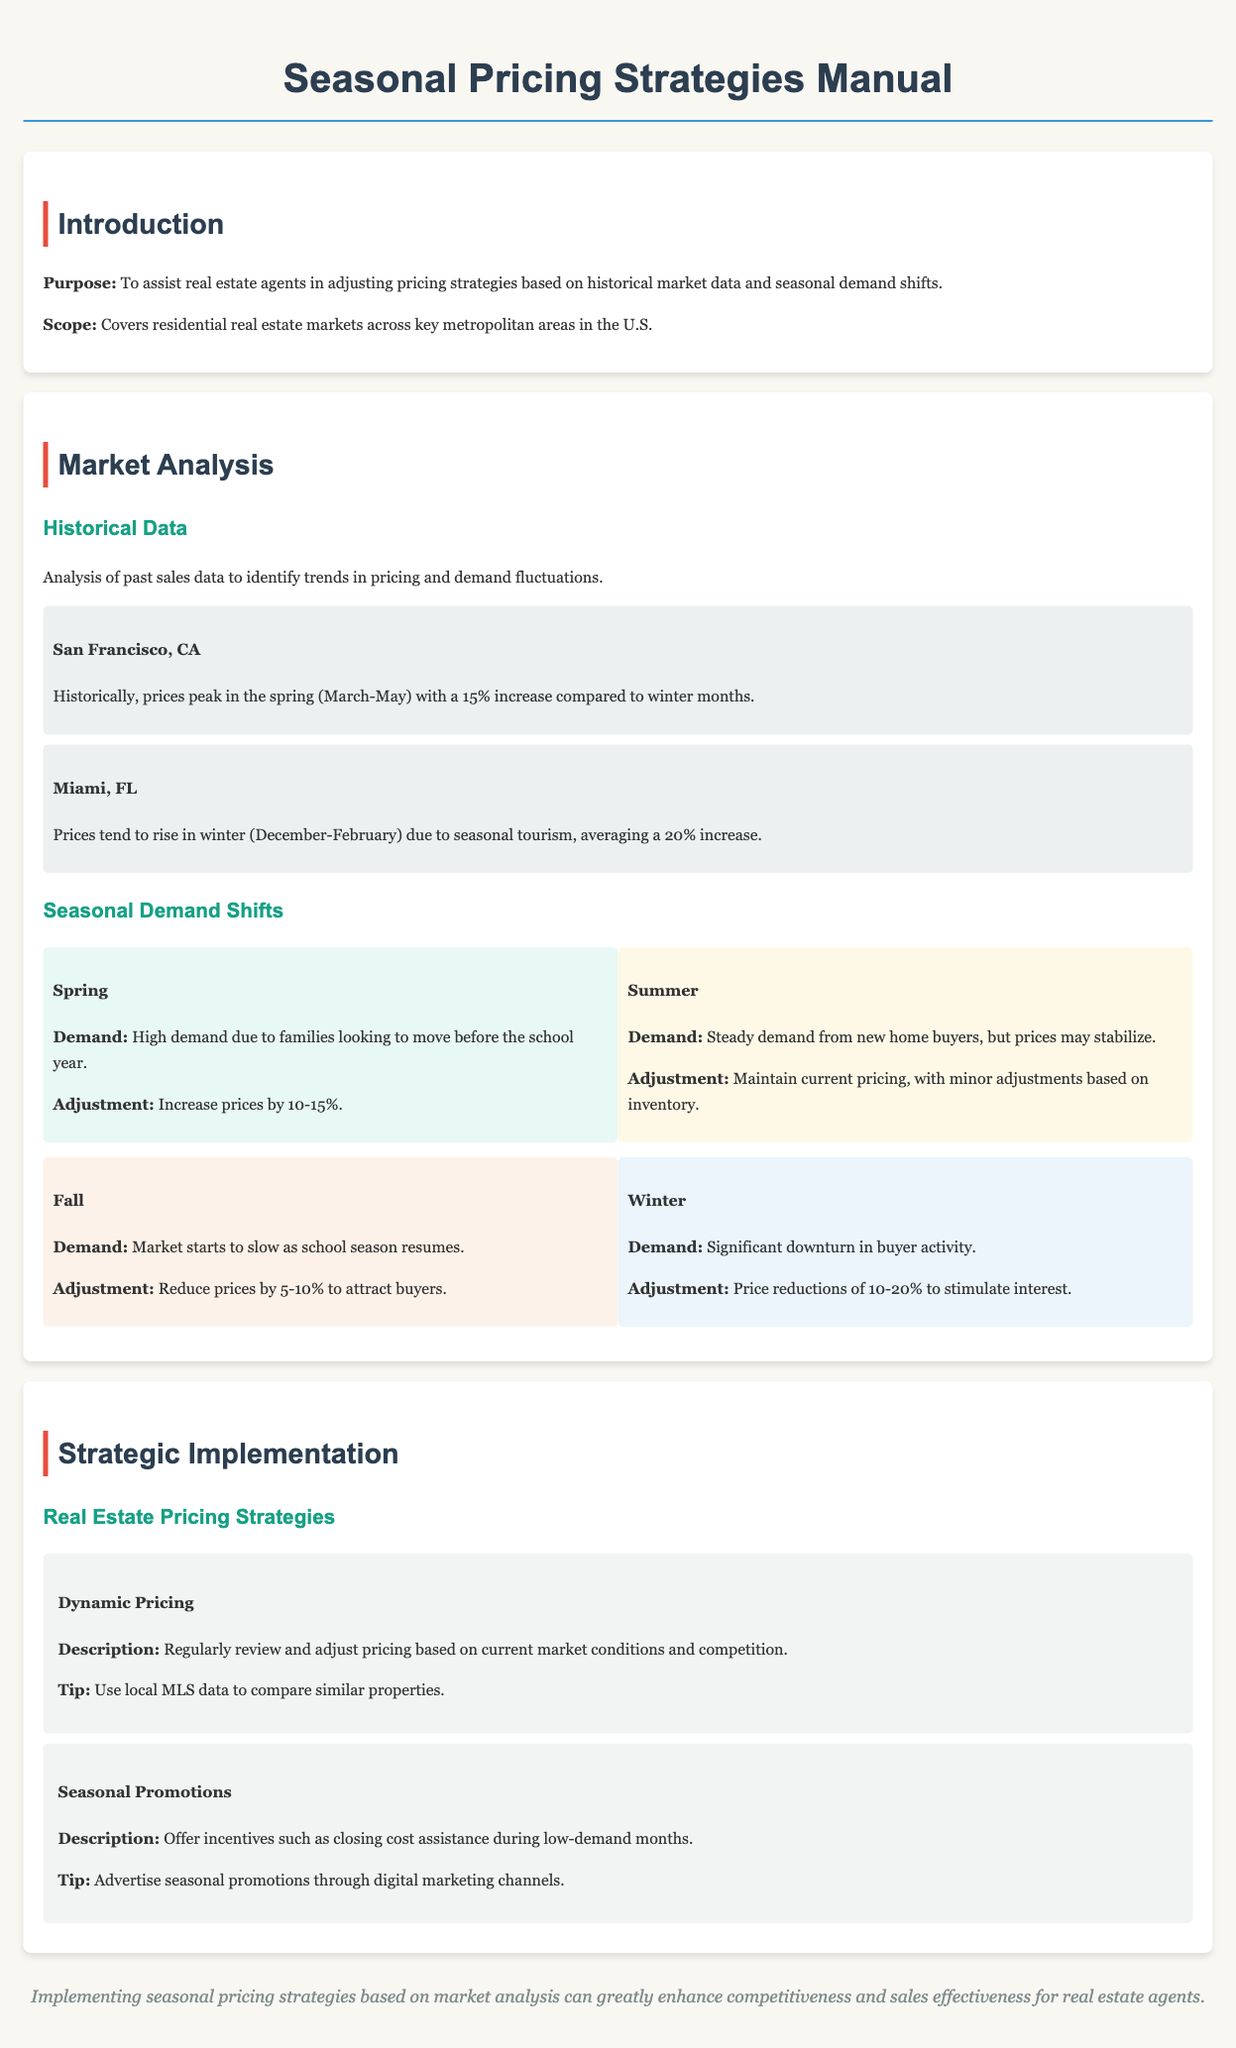What is the purpose of the manual? The purpose is to assist real estate agents in adjusting pricing strategies based on historical market data and seasonal demand shifts.
Answer: Assist real estate agents in adjusting pricing strategies What percentage increase is suggested for spring pricing adjustments? The document states to increase prices by 10-15% during spring.
Answer: 10-15% During which season does Miami, FL see a price increase of 20%? The document specifies that this price increase occurs in winter (December-February).
Answer: Winter (December-February) What is recommended for pricing during the fall season? The document suggests reducing prices by 5-10% to attract buyers during the fall.
Answer: Reduce prices by 5-10% What type of pricing strategy involves regular market reviews? The document describes "Dynamic Pricing" as a strategy that involves regularly reviewing and adjusting prices.
Answer: Dynamic Pricing What does the manual emphasize to stimulate interest in winter? The manual emphasizes price reductions of 10-20% to stimulate interest during winter.
Answer: Price reductions of 10-20% Which city has a historical price peak in spring? San Francisco, CA is mentioned as having historically peaked prices in spring.
Answer: San Francisco, CA What should be used to compare similar properties? The manual recommends using local MLS data for comparing similar properties.
Answer: Local MLS data 